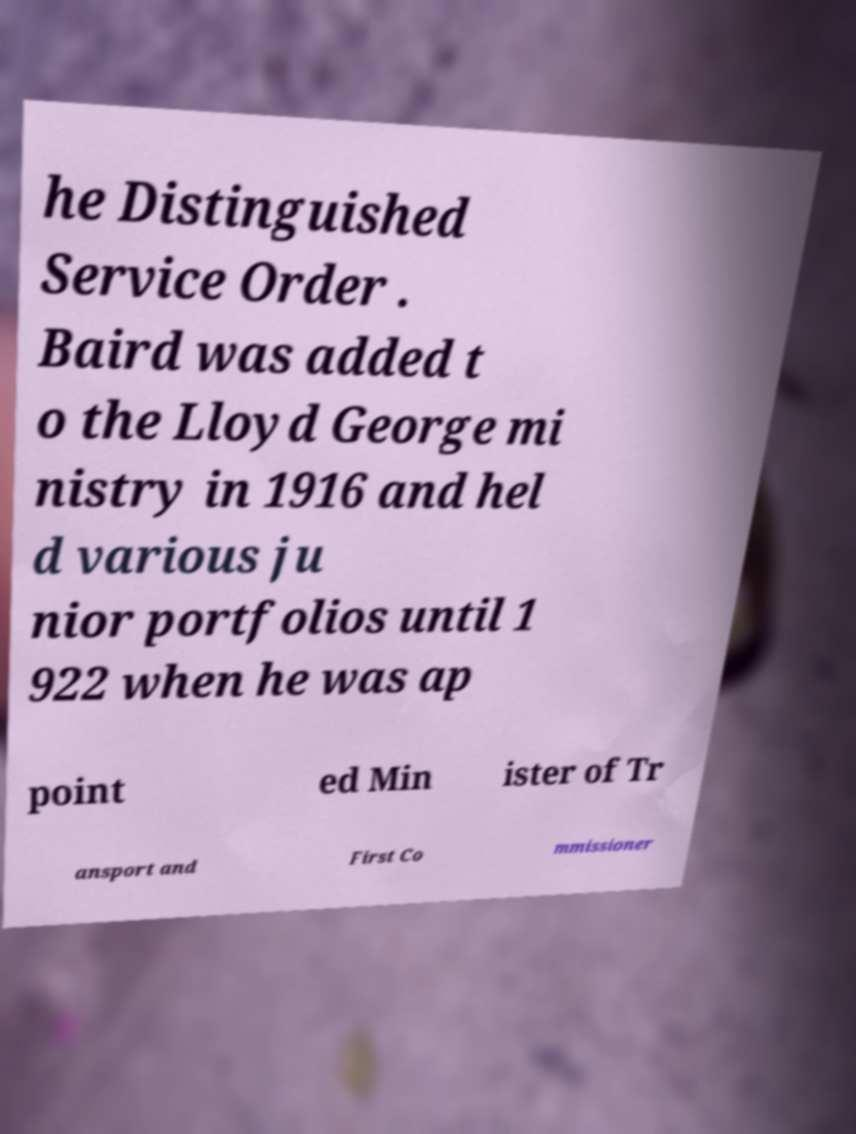Could you assist in decoding the text presented in this image and type it out clearly? he Distinguished Service Order . Baird was added t o the Lloyd George mi nistry in 1916 and hel d various ju nior portfolios until 1 922 when he was ap point ed Min ister of Tr ansport and First Co mmissioner 